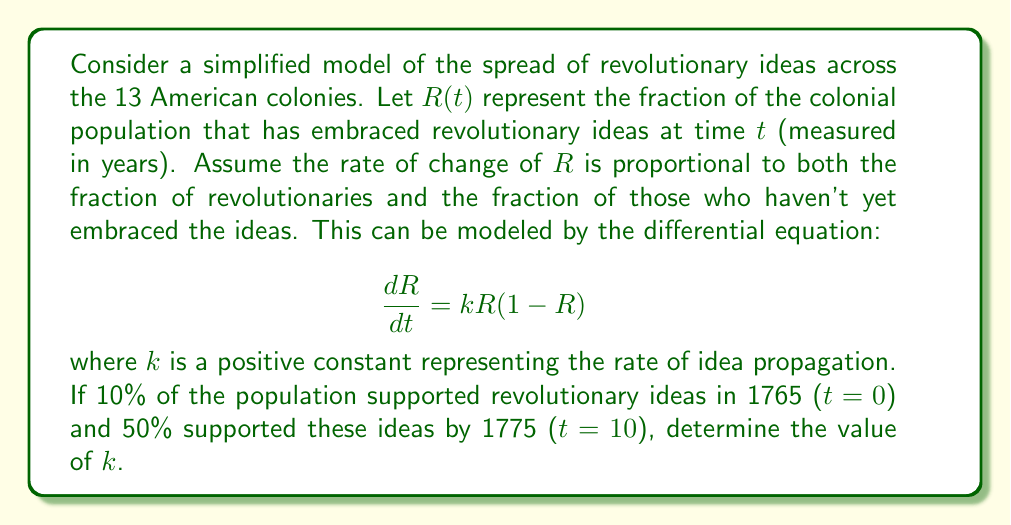Could you help me with this problem? Let's approach this step-by-step:

1) We're given the logistic growth equation: $\frac{dR}{dt} = kR(1-R)$

2) The solution to this differential equation is:

   $$R(t) = \frac{1}{1 + Ce^{-kt}}$$

   where $C$ is a constant determined by the initial conditions.

3) We're given two points:
   At t = 0, R(0) = 0.1
   At t = 10, R(10) = 0.5

4) Let's use the first point to find C:

   $0.1 = \frac{1}{1 + C}$
   $1 + C = 10$
   $C = 9$

5) Now we can use the second point to find k:

   $0.5 = \frac{1}{1 + 9e^{-10k}}$

6) Solving for k:

   $2 = 1 + 9e^{-10k}$
   $1 = 9e^{-10k}$
   $\frac{1}{9} = e^{-10k}$
   $\ln(\frac{1}{9}) = -10k$
   $-\ln(9) = -10k$
   $k = \frac{\ln(9)}{10} \approx 0.2197$
Answer: $k \approx 0.2197$ year$^{-1}$ 